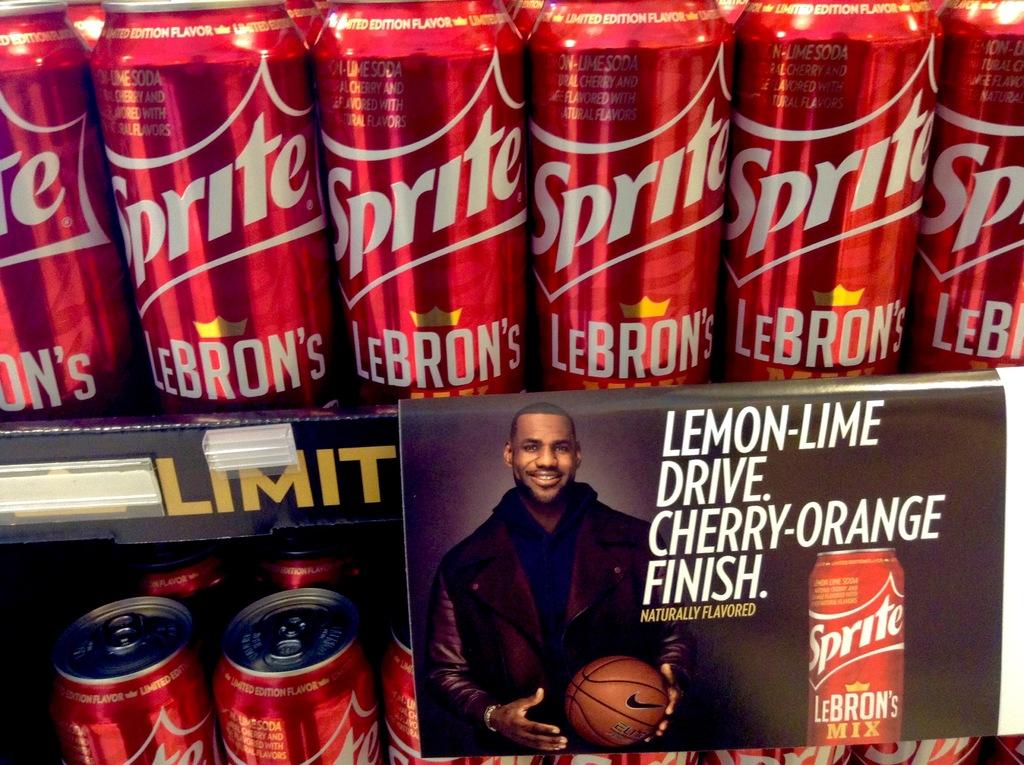What brand of soda is this?
Your answer should be very brief. Sprite. 